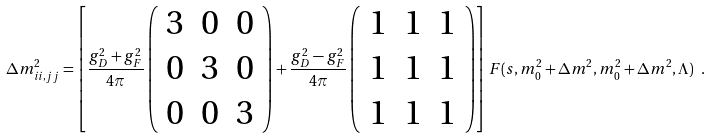<formula> <loc_0><loc_0><loc_500><loc_500>\Delta m _ { i i , j j } ^ { 2 } = \left [ \frac { g _ { D } ^ { 2 } + g _ { F } ^ { 2 } } { 4 \pi } \left ( \begin{array} { c c c } { 3 } & { 0 } & { 0 } \\ { 0 } & { 3 } & { 0 } \\ { 0 } & { 0 } & { 3 } \end{array} \right ) + \frac { g _ { D } ^ { 2 } - g _ { F } ^ { 2 } } { 4 \pi } \left ( \begin{array} { c c c } { 1 } & { 1 } & { 1 } \\ { 1 } & { 1 } & { 1 } \\ { 1 } & { 1 } & { 1 } \end{array} \right ) \right ] F ( s , m _ { 0 } ^ { 2 } + \Delta m ^ { 2 } , m _ { 0 } ^ { 2 } + \Delta m ^ { 2 } , \Lambda ) \ .</formula> 